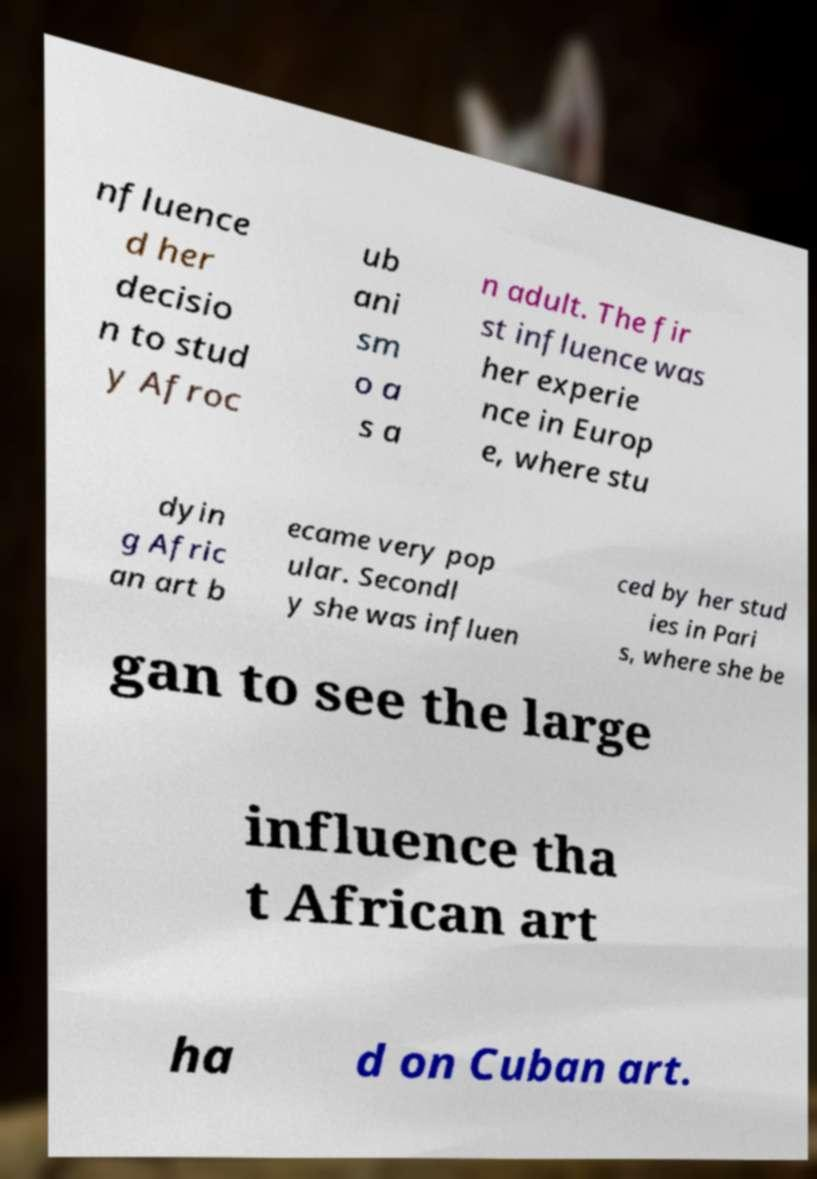Could you assist in decoding the text presented in this image and type it out clearly? nfluence d her decisio n to stud y Afroc ub ani sm o a s a n adult. The fir st influence was her experie nce in Europ e, where stu dyin g Afric an art b ecame very pop ular. Secondl y she was influen ced by her stud ies in Pari s, where she be gan to see the large influence tha t African art ha d on Cuban art. 